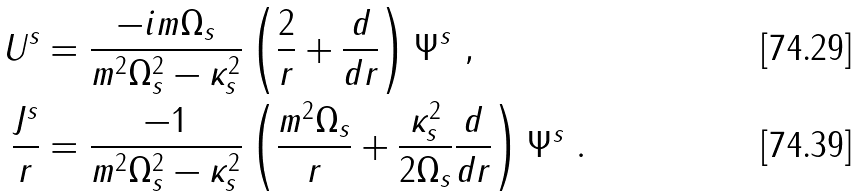<formula> <loc_0><loc_0><loc_500><loc_500>U ^ { s } & = \frac { - i m \Omega _ { s } } { m ^ { 2 } \Omega _ { s } ^ { 2 } - \kappa _ { s } ^ { 2 } } \left ( \frac { 2 } { r } + \frac { d } { d r } \right ) \Psi ^ { s } \ , \\ \frac { J ^ { s } } { r } & = \frac { - 1 } { m ^ { 2 } \Omega _ { s } ^ { 2 } - \kappa _ { s } ^ { 2 } } \left ( \frac { m ^ { 2 } \Omega _ { s } } { r } + \frac { \kappa _ { s } ^ { 2 } } { 2 \Omega _ { s } } \frac { d } { d r } \right ) \Psi ^ { s } \ .</formula> 